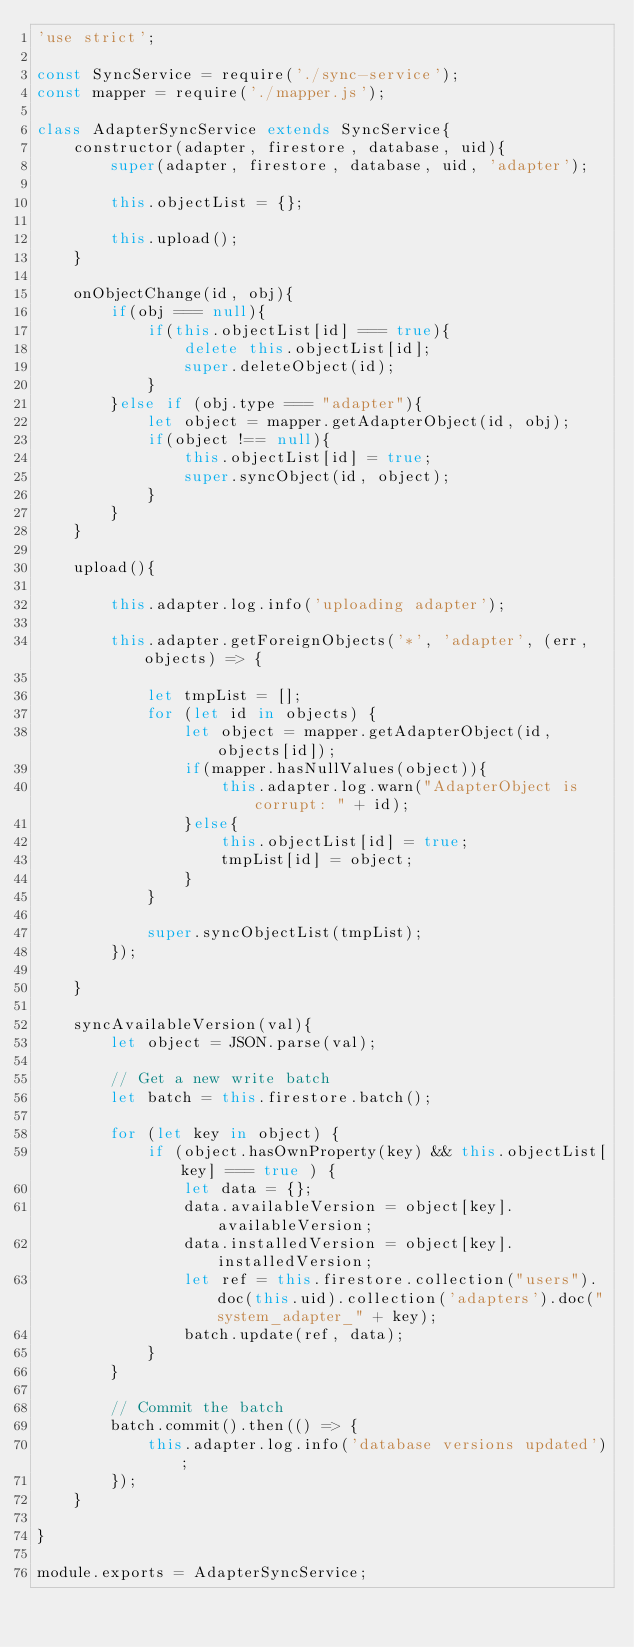Convert code to text. <code><loc_0><loc_0><loc_500><loc_500><_JavaScript_>'use strict';

const SyncService = require('./sync-service');
const mapper = require('./mapper.js');

class AdapterSyncService extends SyncService{
    constructor(adapter, firestore, database, uid){
        super(adapter, firestore, database, uid, 'adapter');

        this.objectList = {};

        this.upload();
    }

    onObjectChange(id, obj){
        if(obj === null){
            if(this.objectList[id] === true){
                delete this.objectList[id];
                super.deleteObject(id);
            }
        }else if (obj.type === "adapter"){
            let object = mapper.getAdapterObject(id, obj);
            if(object !== null){
                this.objectList[id] = true;
                super.syncObject(id, object);
            }
        }
    }

    upload(){

        this.adapter.log.info('uploading adapter');
    
        this.adapter.getForeignObjects('*', 'adapter', (err, objects) => {
            
            let tmpList = [];
            for (let id in objects) {
                let object = mapper.getAdapterObject(id, objects[id]);
                if(mapper.hasNullValues(object)){
                    this.adapter.log.warn("AdapterObject is corrupt: " + id);
                }else{
                    this.objectList[id] = true;
                    tmpList[id] = object;
                }
            }

            super.syncObjectList(tmpList);
        });
    
    }

    syncAvailableVersion(val){
        let object = JSON.parse(val);     

        // Get a new write batch
        let batch = this.firestore.batch();

        for (let key in object) {
            if (object.hasOwnProperty(key) && this.objectList[key] === true ) {
                let data = {};
                data.availableVersion = object[key].availableVersion;
                data.installedVersion = object[key].installedVersion;
                let ref = this.firestore.collection("users").doc(this.uid).collection('adapters').doc("system_adapter_" + key);
                batch.update(ref, data);
            }
        }

        // Commit the batch
        batch.commit().then(() => {
            this.adapter.log.info('database versions updated');
        });
    }

}

module.exports = AdapterSyncService;
</code> 